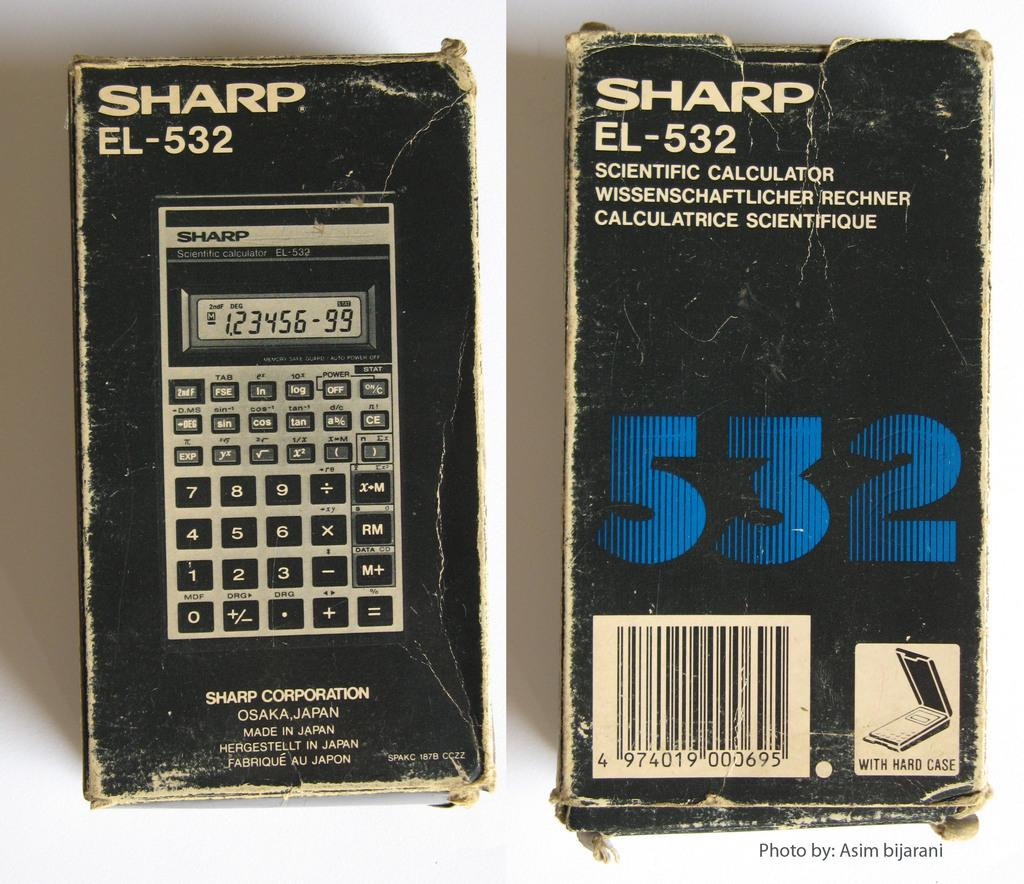What is the main object in the image? There is a scientific calculator box in the image. What is a feature of the calculator box? There is a barcode on the calculator box. What type of mark can be seen on the calculator box made by chalk? There is no mark made by chalk on the calculator box in the image. Is there a twig attached to the calculator box in the image? There is no twig present on or attached to the calculator box in the image. 